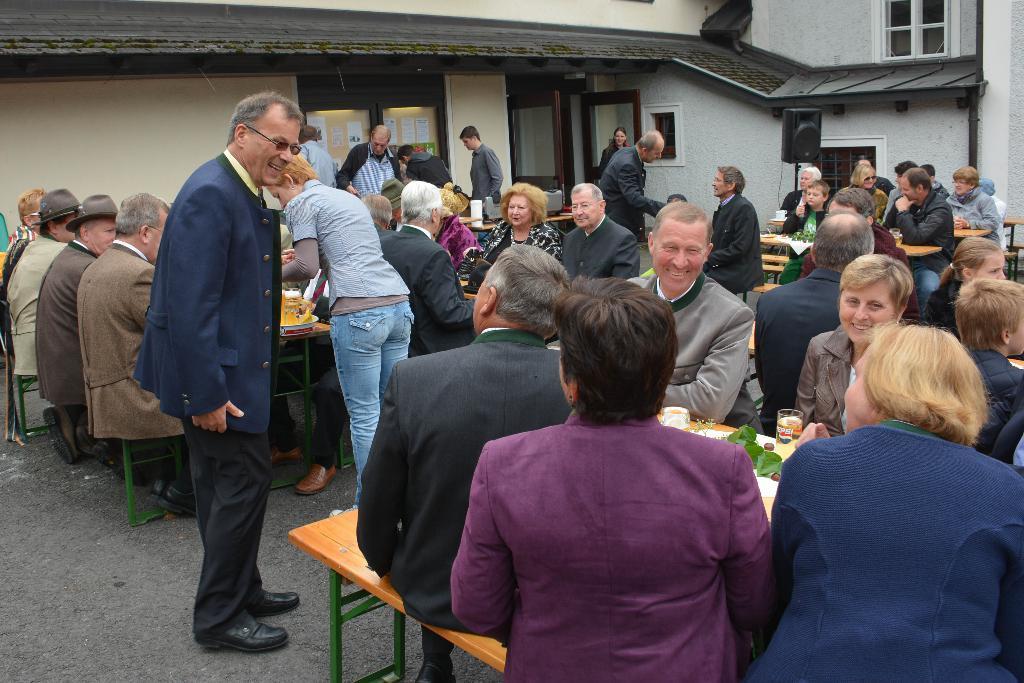Describe this image in one or two sentences. This image consists of many people. It looks like a restaurant. There are many tables and chairs. At the bottom, there is a road. In the background, there are buildings along with windows. 